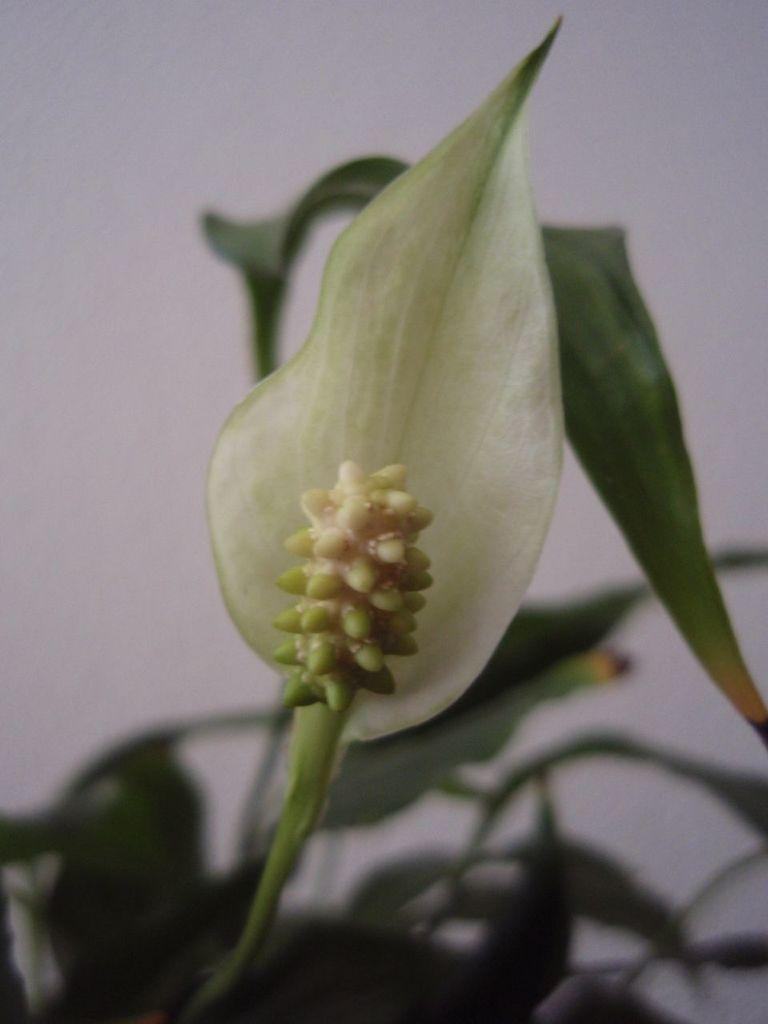What is the main subject of the image? The main subject of the image is a bud on a plant. What color is the background of the image? The background of the image is white. What is the tendency of the spot on the plant in the image? There is no spot present on the plant in the image, so it is not possible to determine any tendency. 